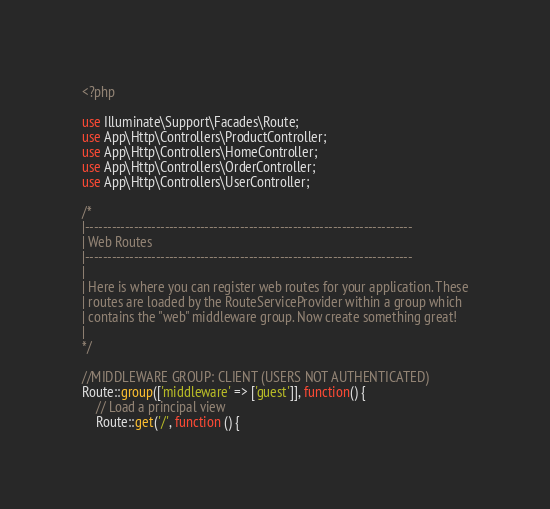Convert code to text. <code><loc_0><loc_0><loc_500><loc_500><_PHP_><?php

use Illuminate\Support\Facades\Route;
use App\Http\Controllers\ProductController;
use App\Http\Controllers\HomeController;
use App\Http\Controllers\OrderController;
use App\Http\Controllers\UserController;

/*
|--------------------------------------------------------------------------
| Web Routes
|--------------------------------------------------------------------------
|
| Here is where you can register web routes for your application. These
| routes are loaded by the RouteServiceProvider within a group which
| contains the "web" middleware group. Now create something great!
|
*/

//MIDDLEWARE GROUP: CLIENT (USERS NOT AUTHENTICATED)
Route::group(['middleware' => ['guest']], function() {
    // Load a principal view
    Route::get('/', function () {</code> 